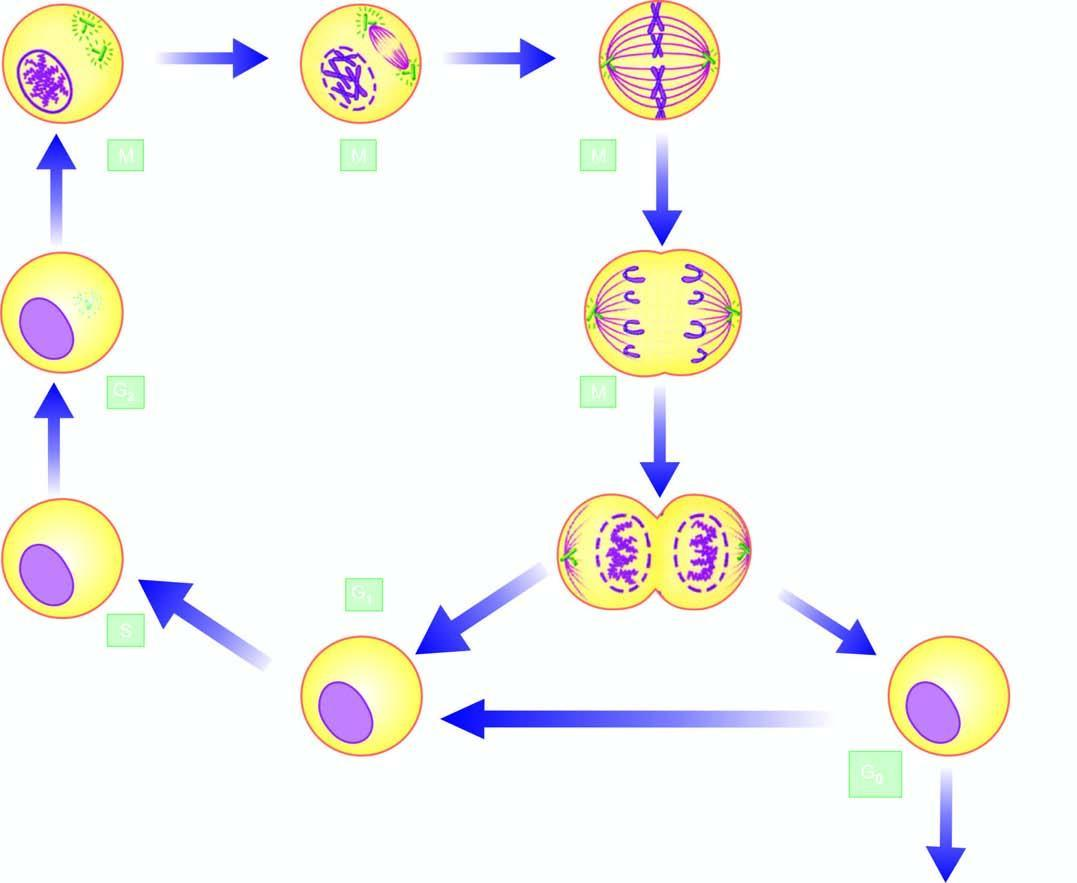what are the g1, s and g2 phase while m phase is accomplished in 4 sequential stages: prophase, metaphase, anaphase, and telophase?
Answer the question using a single word or phrase. Premitotic phases (mitotic) telophase 